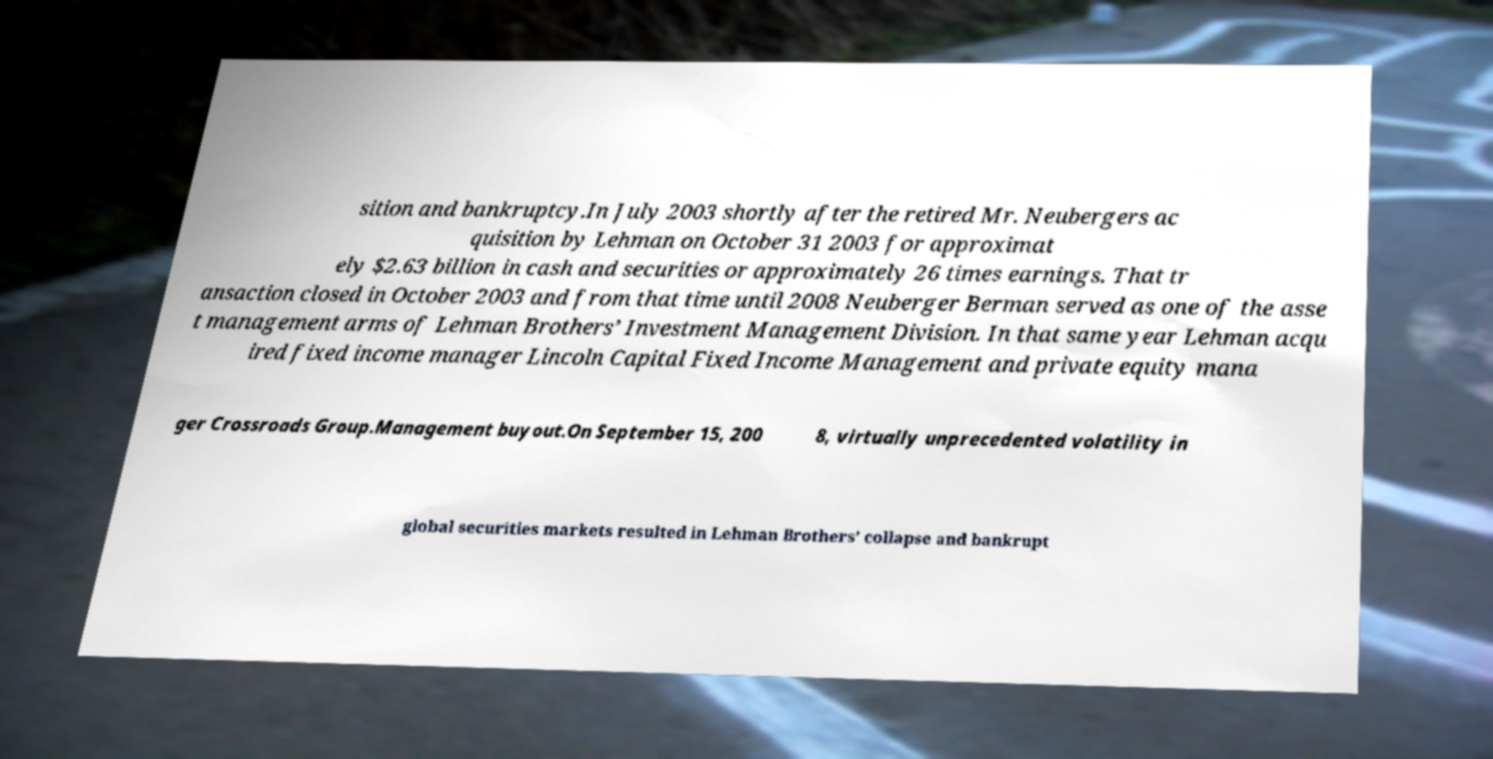I need the written content from this picture converted into text. Can you do that? sition and bankruptcy.In July 2003 shortly after the retired Mr. Neubergers ac quisition by Lehman on October 31 2003 for approximat ely $2.63 billion in cash and securities or approximately 26 times earnings. That tr ansaction closed in October 2003 and from that time until 2008 Neuberger Berman served as one of the asse t management arms of Lehman Brothers’ Investment Management Division. In that same year Lehman acqu ired fixed income manager Lincoln Capital Fixed Income Management and private equity mana ger Crossroads Group.Management buyout.On September 15, 200 8, virtually unprecedented volatility in global securities markets resulted in Lehman Brothers’ collapse and bankrupt 